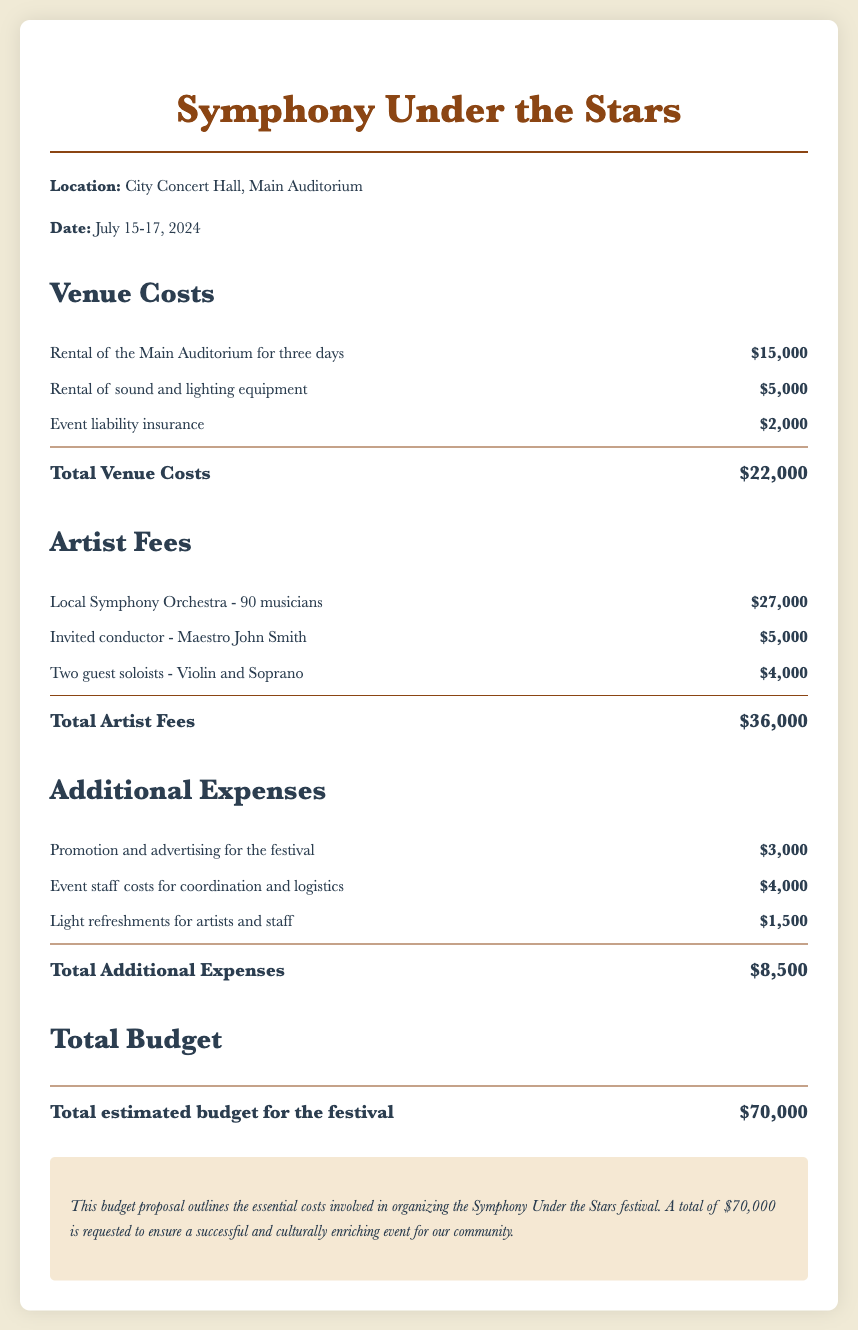what is the location of the festival? The location of the festival is stated in the venue details, which is City Concert Hall, Main Auditorium.
Answer: City Concert Hall, Main Auditorium what are the dates of the festival? The festival dates are explicitly mentioned in the document as July 15-17, 2024.
Answer: July 15-17, 2024 how much is the rental cost of the Main Auditorium? This cost is listed under venue costs, specifically for the rental of the Main Auditorium for three days, which is $15,000.
Answer: $15,000 who is the invited conductor? The document lists the invited conductor as Maestro John Smith.
Answer: Maestro John Smith what is the total for artist fees? The total artist fees are summarized in the artist fees section, which sums up to $36,000.
Answer: $36,000 how much is allocated for promotion and advertising? The promotion and advertising cost for the festival is clearly outlined as $3,000 in the additional expenses section.
Answer: $3,000 what is the total estimated budget for the festival? The total estimated budget is mentioned in the total budget section, which combines all expenses to $70,000.
Answer: $70,000 how much will be spent on light refreshments for artists and staff? The document details the cost for light refreshments for artists and staff as $1,500 in the additional expenses section.
Answer: $1,500 what is the total cost for venue expenses? The total venue costs are summed up in the venue section, explicitly stated as $22,000.
Answer: $22,000 